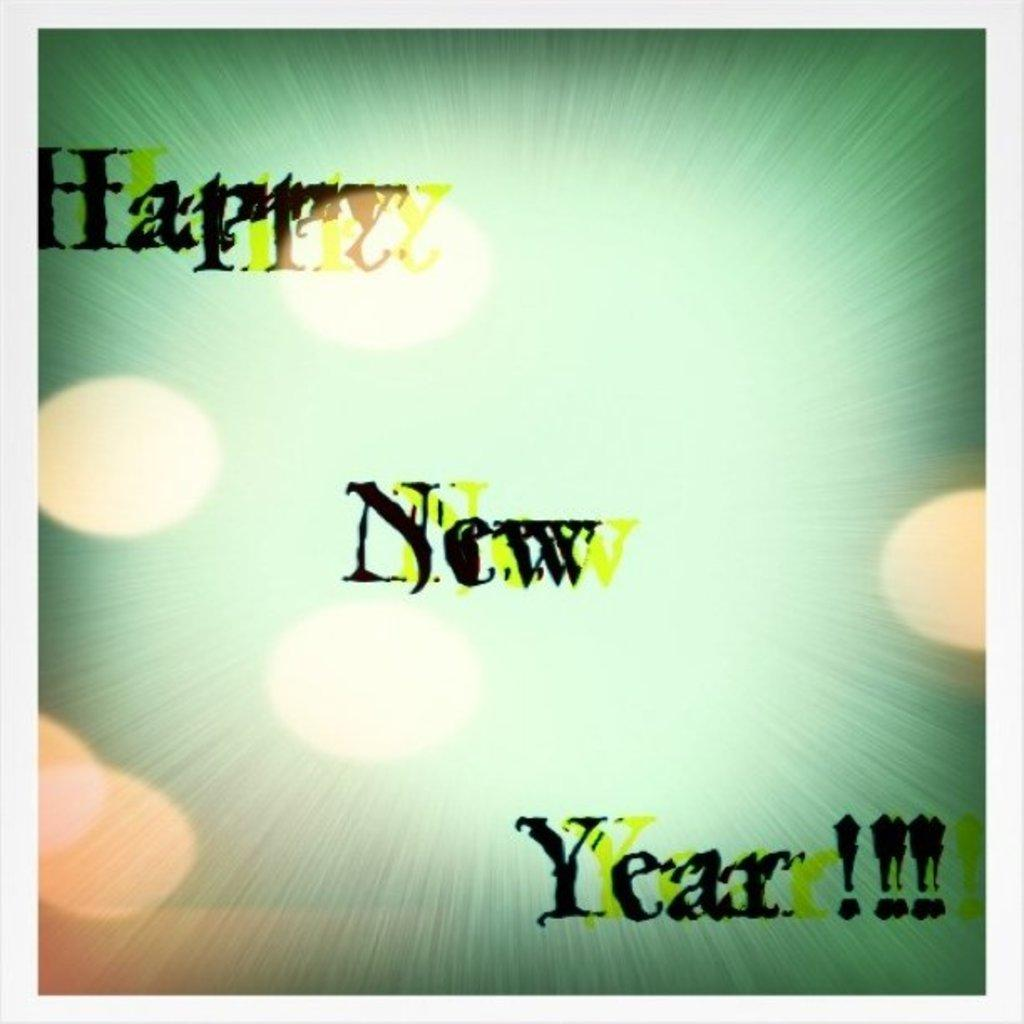<image>
Offer a succinct explanation of the picture presented. A green background with yellow dots showing Happy New Year. 